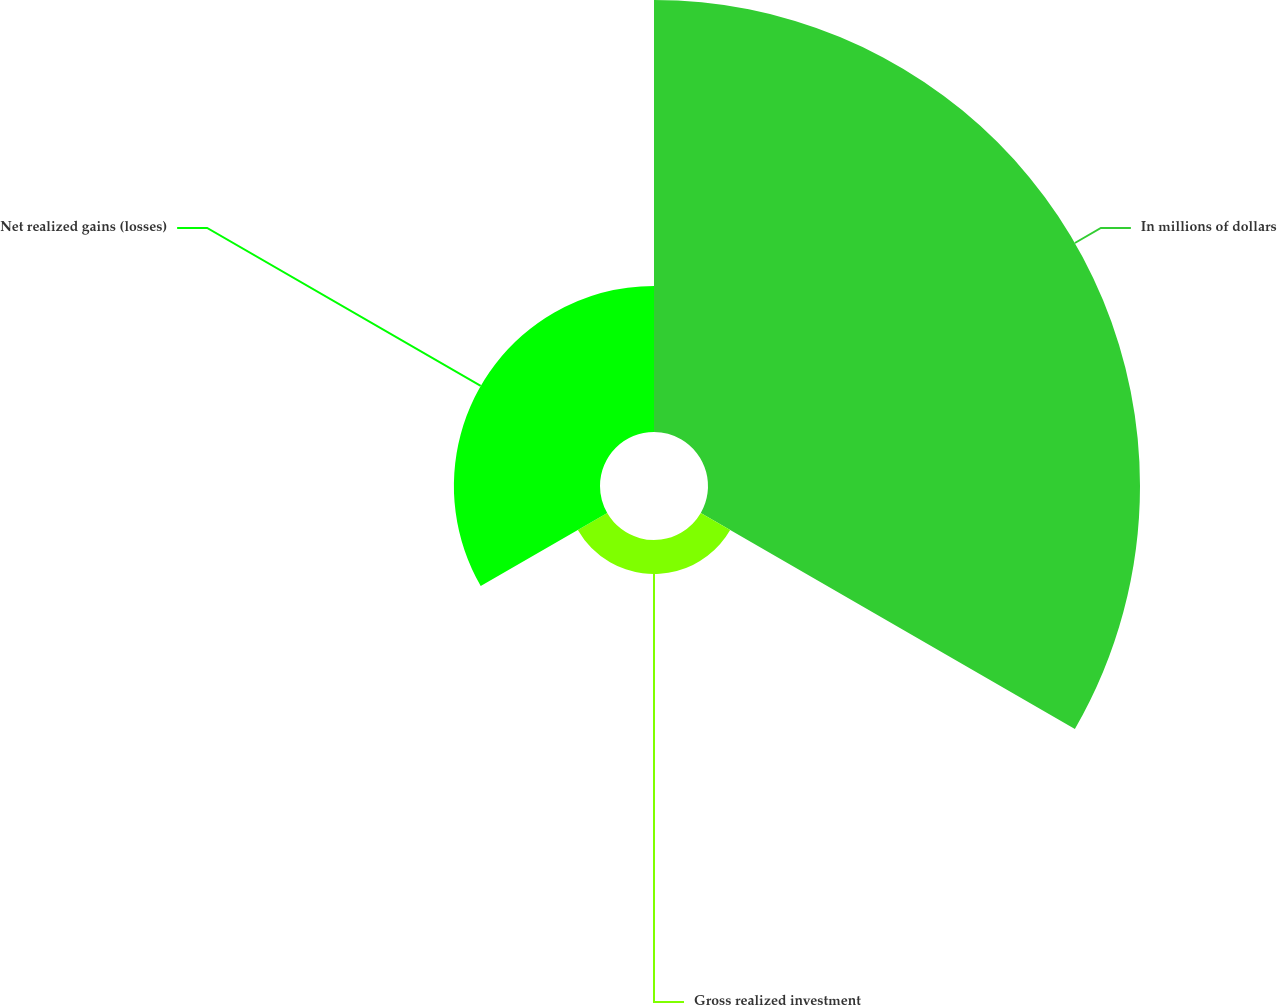<chart> <loc_0><loc_0><loc_500><loc_500><pie_chart><fcel>In millions of dollars<fcel>Gross realized investment<fcel>Net realized gains (losses)<nl><fcel>70.58%<fcel>5.55%<fcel>23.87%<nl></chart> 